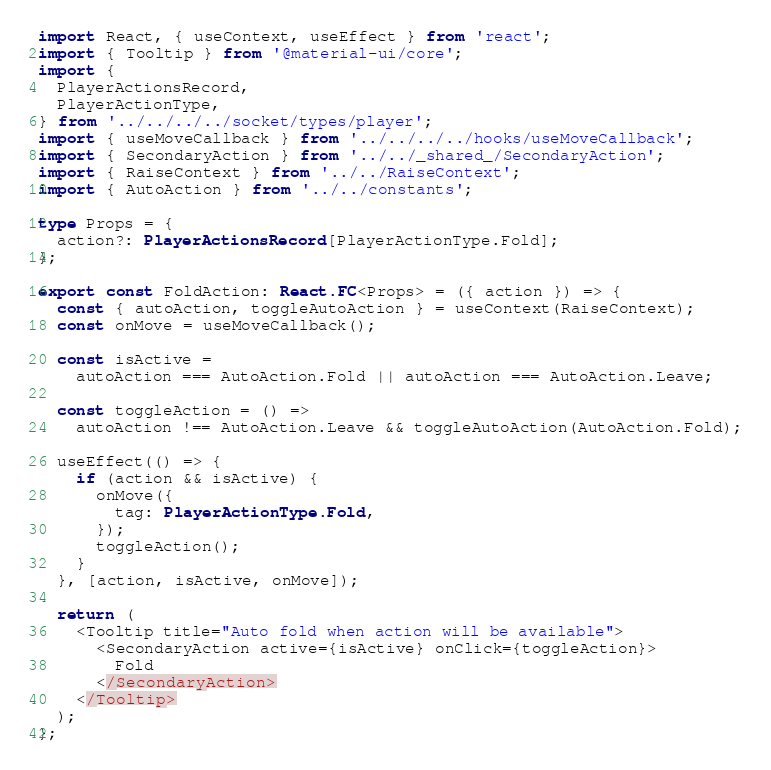<code> <loc_0><loc_0><loc_500><loc_500><_TypeScript_>import React, { useContext, useEffect } from 'react';
import { Tooltip } from '@material-ui/core';
import {
  PlayerActionsRecord,
  PlayerActionType,
} from '../../../../socket/types/player';
import { useMoveCallback } from '../../../../hooks/useMoveCallback';
import { SecondaryAction } from '../../_shared_/SecondaryAction';
import { RaiseContext } from '../../RaiseContext';
import { AutoAction } from '../../constants';

type Props = {
  action?: PlayerActionsRecord[PlayerActionType.Fold];
};

export const FoldAction: React.FC<Props> = ({ action }) => {
  const { autoAction, toggleAutoAction } = useContext(RaiseContext);
  const onMove = useMoveCallback();

  const isActive =
    autoAction === AutoAction.Fold || autoAction === AutoAction.Leave;

  const toggleAction = () =>
    autoAction !== AutoAction.Leave && toggleAutoAction(AutoAction.Fold);

  useEffect(() => {
    if (action && isActive) {
      onMove({
        tag: PlayerActionType.Fold,
      });
      toggleAction();
    }
  }, [action, isActive, onMove]);

  return (
    <Tooltip title="Auto fold when action will be available">
      <SecondaryAction active={isActive} onClick={toggleAction}>
        Fold
      </SecondaryAction>
    </Tooltip>
  );
};
</code> 